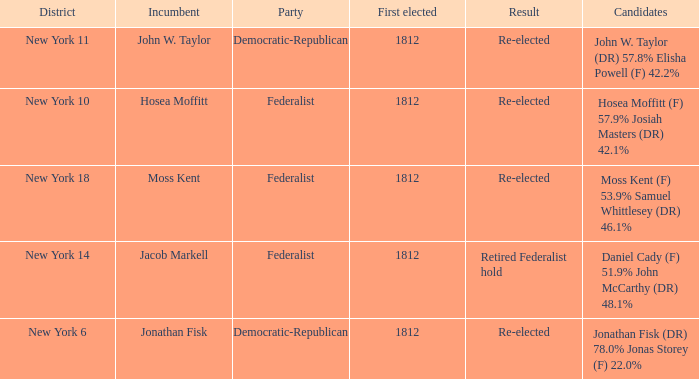Name the most first elected 1812.0. 